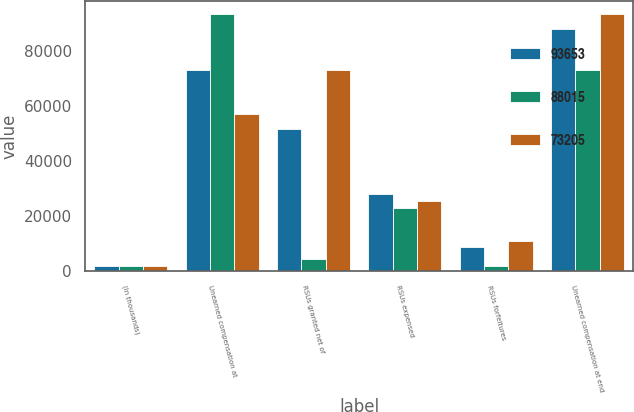<chart> <loc_0><loc_0><loc_500><loc_500><stacked_bar_chart><ecel><fcel>(In thousands)<fcel>Unearned compensation at<fcel>RSUs granted net of<fcel>RSUs expensed<fcel>RSUs forfeitures<fcel>Unearned compensation at end<nl><fcel>93653<fcel>2014<fcel>73205<fcel>51575<fcel>27966<fcel>8799<fcel>88015<nl><fcel>88015<fcel>2013<fcel>93653<fcel>4406<fcel>22881<fcel>1973<fcel>73205<nl><fcel>73205<fcel>2012<fcel>57315<fcel>73255<fcel>25728<fcel>11189<fcel>93653<nl></chart> 